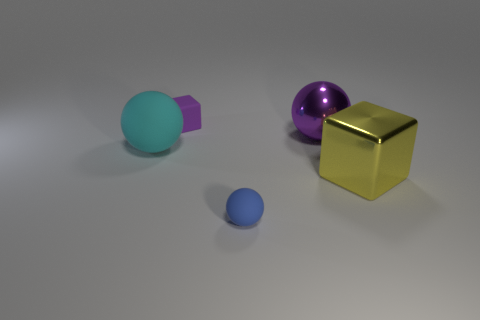Are the cyan sphere and the purple thing that is to the left of the small rubber ball made of the same material? While both the cyan sphere and the purple object exhibit a certain degree of gloss, suggesting a reflective surface, it is not definitive from the image alone whether they are made of the same material, as materials can be treated to have similar finishes. A more detailed examination, possibly considering the context in which they are found, would be necessary to ascertain material composition accurately. 